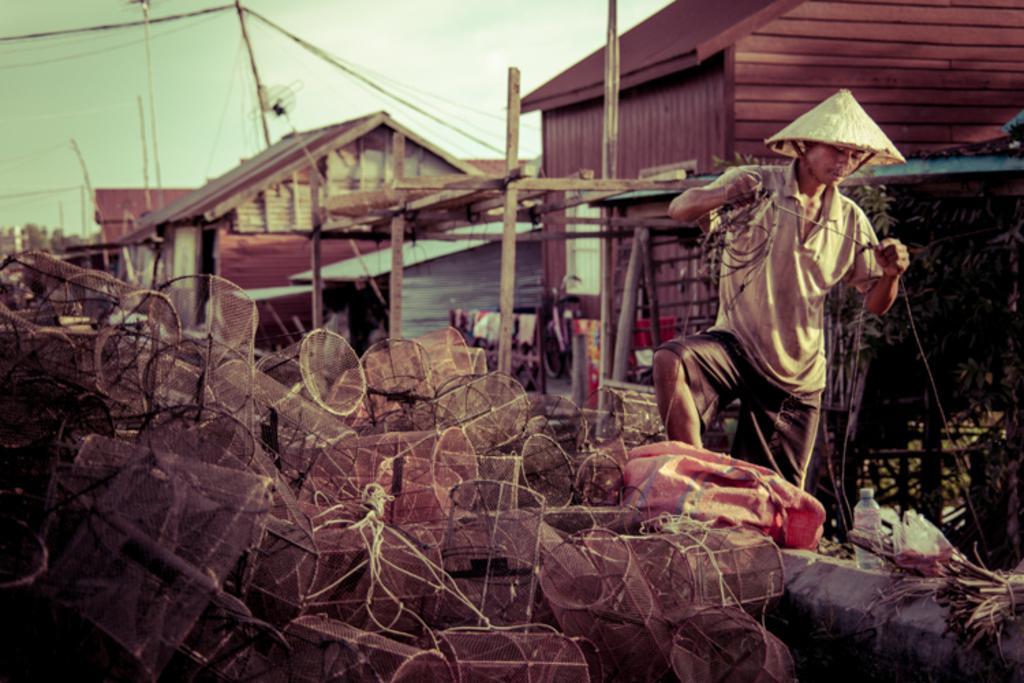Please provide a concise description of this image. In this picture there is a man who is standing on the right side of the image, by holding a rope in his hands, he is wearing a triangular hat, it seems to be there are cages in the center of the image and there are wooden houses, poles, and wires in the background area of the image and there are plants and a boundary on the right side of the image, it seems to be there are clothes in the image and there is a water bottle in the image. 